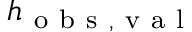<formula> <loc_0><loc_0><loc_500><loc_500>h _ { o b s , v a l }</formula> 